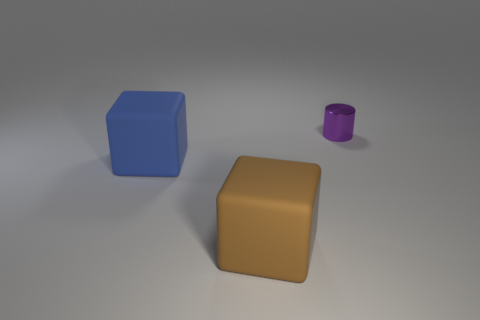How would you describe the lighting in this scene? The lighting in the scene is diffused, coming from above and causing soft shadows to form beneath the objects, which suggests an environment lit by an indirect or ambient light source, such as ceiling lights in an indoor setting. 